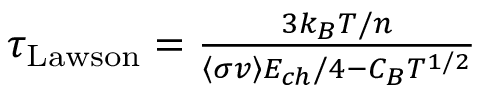<formula> <loc_0><loc_0><loc_500><loc_500>\begin{array} { r } { \tau _ { L a w s o n } = \frac { 3 k _ { B } T / n } { \left \langle \sigma v \right \rangle E _ { c h } / 4 - C _ { B } T ^ { 1 / 2 } } } \end{array}</formula> 